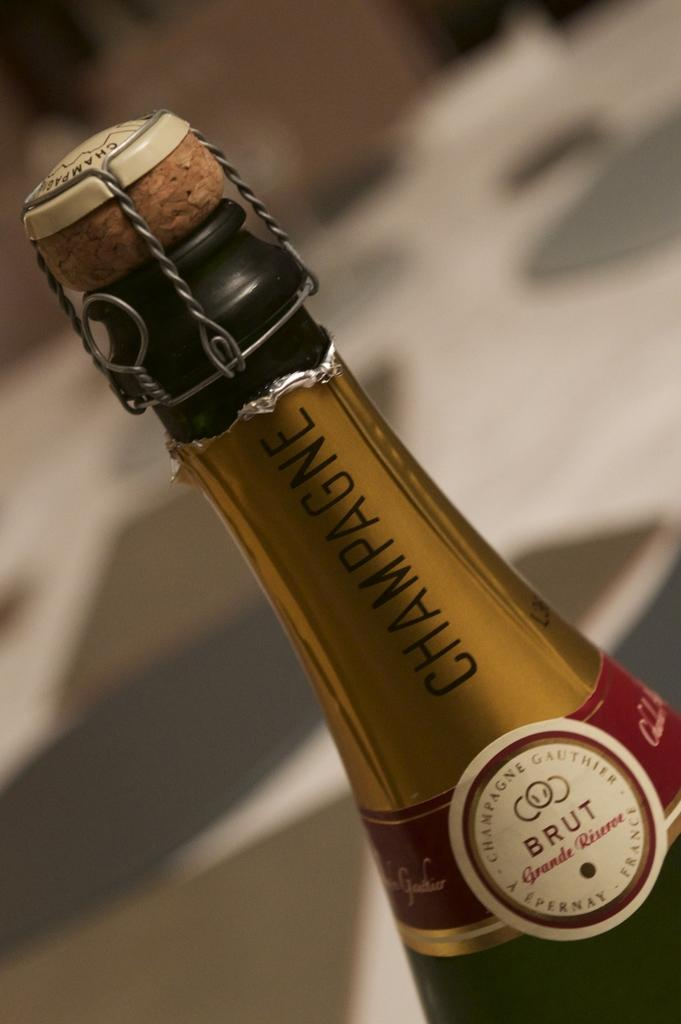<image>
Write a terse but informative summary of the picture. A bottle of Brut champagne has the cork in it still. 